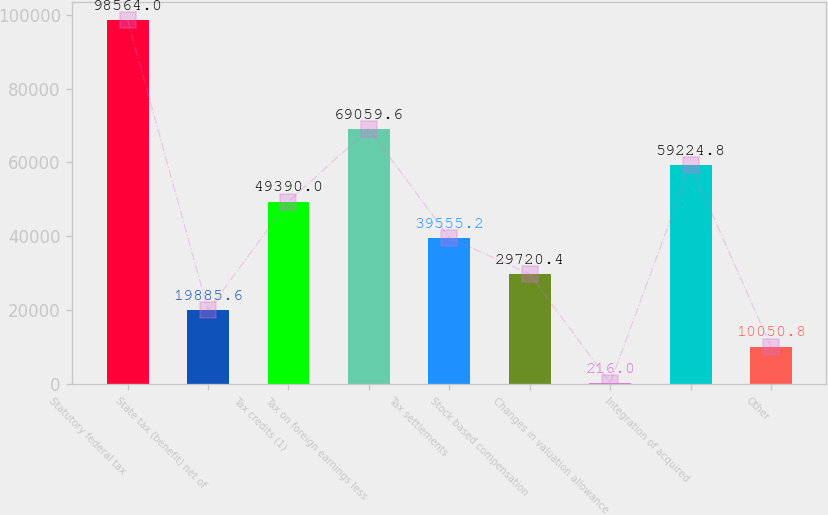<chart> <loc_0><loc_0><loc_500><loc_500><bar_chart><fcel>Statutory federal tax<fcel>State tax (benefit) net of<fcel>Tax credits (1)<fcel>Tax on foreign earnings less<fcel>Tax settlements<fcel>Stock based compensation<fcel>Changes in valuation allowance<fcel>Integration of acquired<fcel>Other<nl><fcel>98564<fcel>19885.6<fcel>49390<fcel>69059.6<fcel>39555.2<fcel>29720.4<fcel>216<fcel>59224.8<fcel>10050.8<nl></chart> 